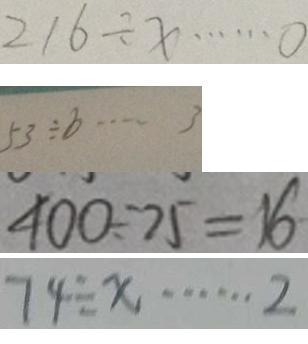<formula> <loc_0><loc_0><loc_500><loc_500>2 1 6 \div x \cdots 0 
 5 3 \div b \cdots 3 
 4 0 0 \div 7 5 = 1 6 
 7 4 \div x \cdots 2</formula> 